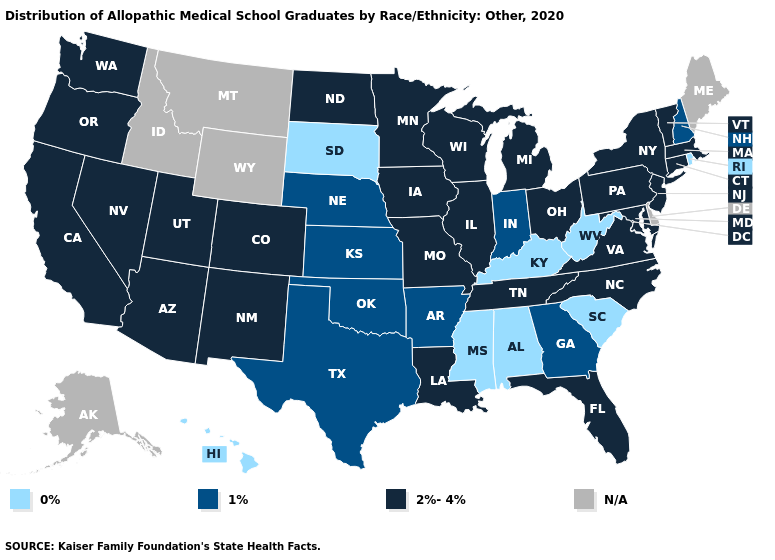How many symbols are there in the legend?
Short answer required. 4. Does South Dakota have the lowest value in the USA?
Write a very short answer. Yes. Which states hav the highest value in the South?
Be succinct. Florida, Louisiana, Maryland, North Carolina, Tennessee, Virginia. What is the value of Indiana?
Keep it brief. 1%. Does West Virginia have the highest value in the South?
Concise answer only. No. Which states have the lowest value in the MidWest?
Write a very short answer. South Dakota. Name the states that have a value in the range 0%?
Write a very short answer. Alabama, Hawaii, Kentucky, Mississippi, Rhode Island, South Carolina, South Dakota, West Virginia. What is the value of Montana?
Keep it brief. N/A. Among the states that border Missouri , which have the highest value?
Be succinct. Illinois, Iowa, Tennessee. Is the legend a continuous bar?
Be succinct. No. Does the first symbol in the legend represent the smallest category?
Short answer required. Yes. Is the legend a continuous bar?
Short answer required. No. Does Arizona have the highest value in the West?
Short answer required. Yes. What is the highest value in the USA?
Short answer required. 2%-4%. 